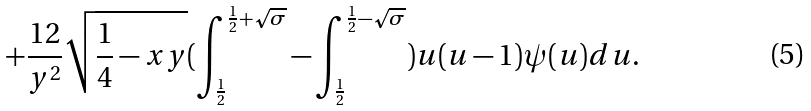Convert formula to latex. <formula><loc_0><loc_0><loc_500><loc_500>+ \frac { 1 2 } { y ^ { 2 } } \sqrt { \frac { 1 } { 4 } - x y } ( \int _ { \frac { 1 } { 2 } } ^ { \frac { 1 } { 2 } + \sqrt { \sigma } } - \int _ { \frac { 1 } { 2 } } ^ { \frac { 1 } { 2 } - \sqrt { \sigma } } ) u ( u - 1 ) \psi ( u ) d u .</formula> 